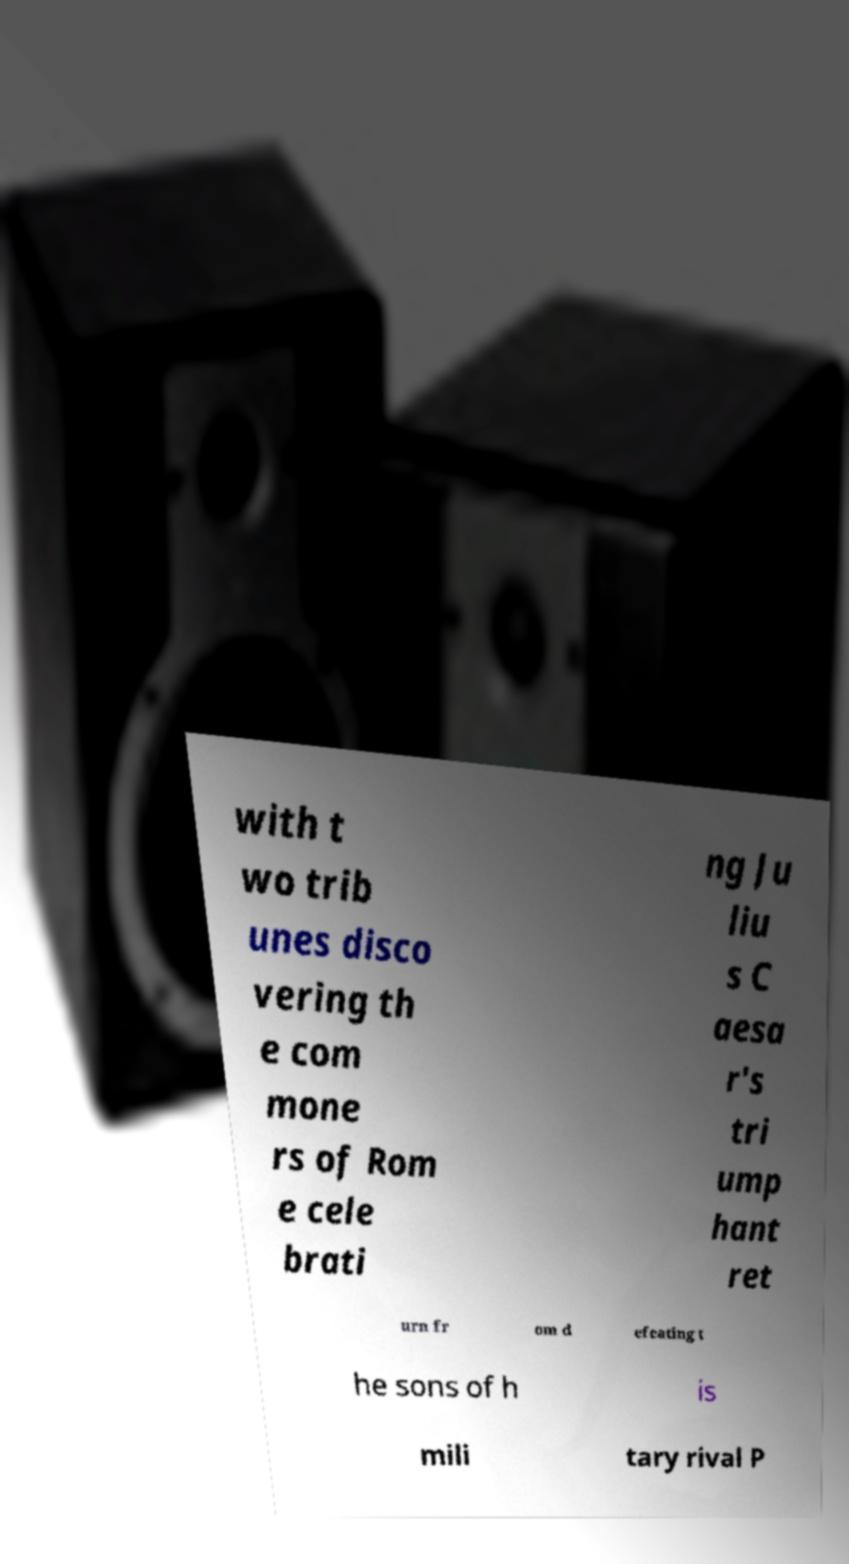For documentation purposes, I need the text within this image transcribed. Could you provide that? with t wo trib unes disco vering th e com mone rs of Rom e cele brati ng Ju liu s C aesa r's tri ump hant ret urn fr om d efeating t he sons of h is mili tary rival P 